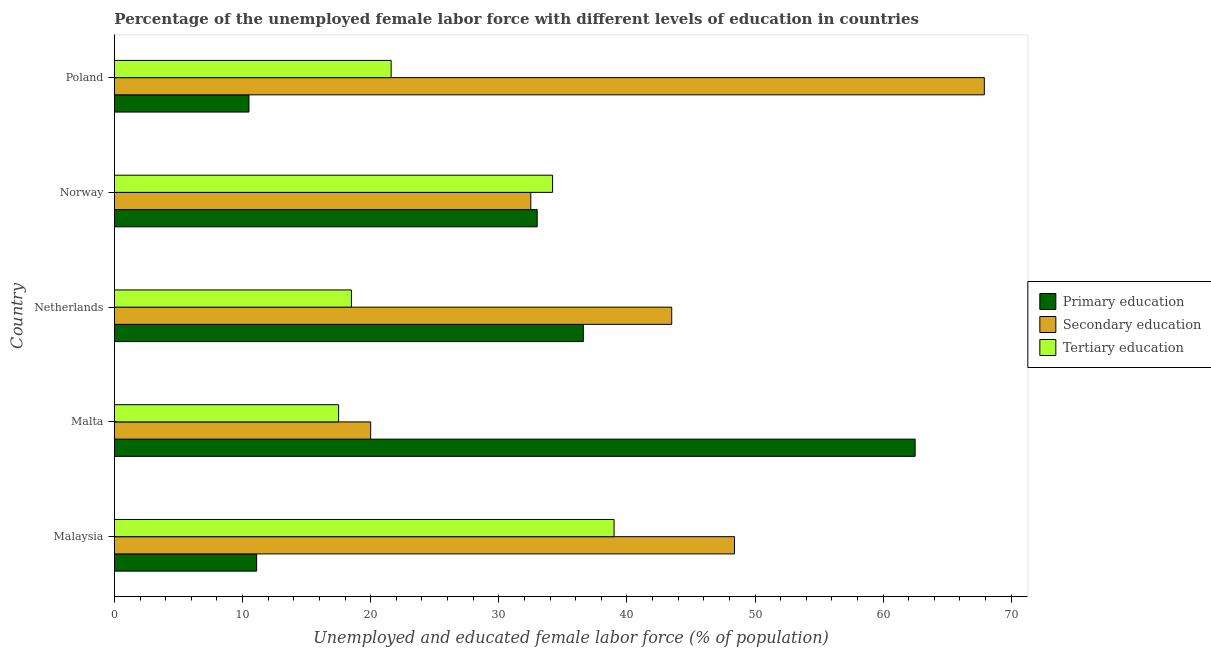How many groups of bars are there?
Offer a terse response. 5. Are the number of bars per tick equal to the number of legend labels?
Offer a very short reply. Yes. How many bars are there on the 5th tick from the bottom?
Provide a short and direct response. 3. In how many cases, is the number of bars for a given country not equal to the number of legend labels?
Keep it short and to the point. 0. Across all countries, what is the maximum percentage of female labor force who received primary education?
Provide a short and direct response. 62.5. Across all countries, what is the minimum percentage of female labor force who received secondary education?
Offer a very short reply. 20. In which country was the percentage of female labor force who received secondary education maximum?
Offer a very short reply. Poland. In which country was the percentage of female labor force who received secondary education minimum?
Provide a short and direct response. Malta. What is the total percentage of female labor force who received secondary education in the graph?
Provide a short and direct response. 212.3. What is the difference between the percentage of female labor force who received secondary education in Malaysia and the percentage of female labor force who received tertiary education in Netherlands?
Your answer should be very brief. 29.9. What is the average percentage of female labor force who received tertiary education per country?
Your answer should be very brief. 26.16. What is the difference between the percentage of female labor force who received tertiary education and percentage of female labor force who received secondary education in Poland?
Make the answer very short. -46.3. What is the ratio of the percentage of female labor force who received tertiary education in Netherlands to that in Poland?
Keep it short and to the point. 0.86. What is the difference between the highest and the second highest percentage of female labor force who received primary education?
Give a very brief answer. 25.9. What is the difference between the highest and the lowest percentage of female labor force who received secondary education?
Offer a terse response. 47.9. What does the 3rd bar from the top in Poland represents?
Give a very brief answer. Primary education. What does the 2nd bar from the bottom in Malaysia represents?
Your answer should be compact. Secondary education. Is it the case that in every country, the sum of the percentage of female labor force who received primary education and percentage of female labor force who received secondary education is greater than the percentage of female labor force who received tertiary education?
Offer a terse response. Yes. What is the difference between two consecutive major ticks on the X-axis?
Your answer should be very brief. 10. Does the graph contain any zero values?
Make the answer very short. No. Does the graph contain grids?
Keep it short and to the point. No. How many legend labels are there?
Provide a succinct answer. 3. What is the title of the graph?
Ensure brevity in your answer.  Percentage of the unemployed female labor force with different levels of education in countries. Does "Textiles and clothing" appear as one of the legend labels in the graph?
Give a very brief answer. No. What is the label or title of the X-axis?
Make the answer very short. Unemployed and educated female labor force (% of population). What is the Unemployed and educated female labor force (% of population) of Primary education in Malaysia?
Ensure brevity in your answer.  11.1. What is the Unemployed and educated female labor force (% of population) of Secondary education in Malaysia?
Keep it short and to the point. 48.4. What is the Unemployed and educated female labor force (% of population) in Tertiary education in Malaysia?
Ensure brevity in your answer.  39. What is the Unemployed and educated female labor force (% of population) of Primary education in Malta?
Your response must be concise. 62.5. What is the Unemployed and educated female labor force (% of population) in Secondary education in Malta?
Your response must be concise. 20. What is the Unemployed and educated female labor force (% of population) in Tertiary education in Malta?
Offer a terse response. 17.5. What is the Unemployed and educated female labor force (% of population) in Primary education in Netherlands?
Give a very brief answer. 36.6. What is the Unemployed and educated female labor force (% of population) in Secondary education in Netherlands?
Offer a very short reply. 43.5. What is the Unemployed and educated female labor force (% of population) of Secondary education in Norway?
Offer a terse response. 32.5. What is the Unemployed and educated female labor force (% of population) of Tertiary education in Norway?
Offer a terse response. 34.2. What is the Unemployed and educated female labor force (% of population) in Secondary education in Poland?
Offer a very short reply. 67.9. What is the Unemployed and educated female labor force (% of population) in Tertiary education in Poland?
Your response must be concise. 21.6. Across all countries, what is the maximum Unemployed and educated female labor force (% of population) in Primary education?
Ensure brevity in your answer.  62.5. Across all countries, what is the maximum Unemployed and educated female labor force (% of population) of Secondary education?
Ensure brevity in your answer.  67.9. Across all countries, what is the maximum Unemployed and educated female labor force (% of population) in Tertiary education?
Keep it short and to the point. 39. Across all countries, what is the minimum Unemployed and educated female labor force (% of population) in Secondary education?
Provide a short and direct response. 20. What is the total Unemployed and educated female labor force (% of population) of Primary education in the graph?
Your answer should be very brief. 153.7. What is the total Unemployed and educated female labor force (% of population) in Secondary education in the graph?
Your answer should be compact. 212.3. What is the total Unemployed and educated female labor force (% of population) of Tertiary education in the graph?
Offer a terse response. 130.8. What is the difference between the Unemployed and educated female labor force (% of population) in Primary education in Malaysia and that in Malta?
Provide a short and direct response. -51.4. What is the difference between the Unemployed and educated female labor force (% of population) in Secondary education in Malaysia and that in Malta?
Give a very brief answer. 28.4. What is the difference between the Unemployed and educated female labor force (% of population) in Tertiary education in Malaysia and that in Malta?
Offer a very short reply. 21.5. What is the difference between the Unemployed and educated female labor force (% of population) of Primary education in Malaysia and that in Netherlands?
Ensure brevity in your answer.  -25.5. What is the difference between the Unemployed and educated female labor force (% of population) of Secondary education in Malaysia and that in Netherlands?
Keep it short and to the point. 4.9. What is the difference between the Unemployed and educated female labor force (% of population) in Primary education in Malaysia and that in Norway?
Offer a very short reply. -21.9. What is the difference between the Unemployed and educated female labor force (% of population) in Tertiary education in Malaysia and that in Norway?
Keep it short and to the point. 4.8. What is the difference between the Unemployed and educated female labor force (% of population) in Secondary education in Malaysia and that in Poland?
Offer a very short reply. -19.5. What is the difference between the Unemployed and educated female labor force (% of population) in Primary education in Malta and that in Netherlands?
Keep it short and to the point. 25.9. What is the difference between the Unemployed and educated female labor force (% of population) of Secondary education in Malta and that in Netherlands?
Give a very brief answer. -23.5. What is the difference between the Unemployed and educated female labor force (% of population) in Primary education in Malta and that in Norway?
Your answer should be very brief. 29.5. What is the difference between the Unemployed and educated female labor force (% of population) of Tertiary education in Malta and that in Norway?
Offer a terse response. -16.7. What is the difference between the Unemployed and educated female labor force (% of population) in Secondary education in Malta and that in Poland?
Provide a short and direct response. -47.9. What is the difference between the Unemployed and educated female labor force (% of population) of Secondary education in Netherlands and that in Norway?
Make the answer very short. 11. What is the difference between the Unemployed and educated female labor force (% of population) of Tertiary education in Netherlands and that in Norway?
Keep it short and to the point. -15.7. What is the difference between the Unemployed and educated female labor force (% of population) in Primary education in Netherlands and that in Poland?
Provide a succinct answer. 26.1. What is the difference between the Unemployed and educated female labor force (% of population) in Secondary education in Netherlands and that in Poland?
Offer a very short reply. -24.4. What is the difference between the Unemployed and educated female labor force (% of population) of Secondary education in Norway and that in Poland?
Offer a terse response. -35.4. What is the difference between the Unemployed and educated female labor force (% of population) of Tertiary education in Norway and that in Poland?
Ensure brevity in your answer.  12.6. What is the difference between the Unemployed and educated female labor force (% of population) in Primary education in Malaysia and the Unemployed and educated female labor force (% of population) in Tertiary education in Malta?
Make the answer very short. -6.4. What is the difference between the Unemployed and educated female labor force (% of population) of Secondary education in Malaysia and the Unemployed and educated female labor force (% of population) of Tertiary education in Malta?
Your answer should be very brief. 30.9. What is the difference between the Unemployed and educated female labor force (% of population) in Primary education in Malaysia and the Unemployed and educated female labor force (% of population) in Secondary education in Netherlands?
Ensure brevity in your answer.  -32.4. What is the difference between the Unemployed and educated female labor force (% of population) of Primary education in Malaysia and the Unemployed and educated female labor force (% of population) of Tertiary education in Netherlands?
Your answer should be compact. -7.4. What is the difference between the Unemployed and educated female labor force (% of population) in Secondary education in Malaysia and the Unemployed and educated female labor force (% of population) in Tertiary education in Netherlands?
Offer a terse response. 29.9. What is the difference between the Unemployed and educated female labor force (% of population) in Primary education in Malaysia and the Unemployed and educated female labor force (% of population) in Secondary education in Norway?
Ensure brevity in your answer.  -21.4. What is the difference between the Unemployed and educated female labor force (% of population) in Primary education in Malaysia and the Unemployed and educated female labor force (% of population) in Tertiary education in Norway?
Keep it short and to the point. -23.1. What is the difference between the Unemployed and educated female labor force (% of population) in Primary education in Malaysia and the Unemployed and educated female labor force (% of population) in Secondary education in Poland?
Your response must be concise. -56.8. What is the difference between the Unemployed and educated female labor force (% of population) of Primary education in Malaysia and the Unemployed and educated female labor force (% of population) of Tertiary education in Poland?
Your response must be concise. -10.5. What is the difference between the Unemployed and educated female labor force (% of population) in Secondary education in Malaysia and the Unemployed and educated female labor force (% of population) in Tertiary education in Poland?
Provide a succinct answer. 26.8. What is the difference between the Unemployed and educated female labor force (% of population) of Primary education in Malta and the Unemployed and educated female labor force (% of population) of Secondary education in Netherlands?
Your answer should be very brief. 19. What is the difference between the Unemployed and educated female labor force (% of population) in Primary education in Malta and the Unemployed and educated female labor force (% of population) in Secondary education in Norway?
Keep it short and to the point. 30. What is the difference between the Unemployed and educated female labor force (% of population) of Primary education in Malta and the Unemployed and educated female labor force (% of population) of Tertiary education in Norway?
Make the answer very short. 28.3. What is the difference between the Unemployed and educated female labor force (% of population) in Primary education in Malta and the Unemployed and educated female labor force (% of population) in Secondary education in Poland?
Make the answer very short. -5.4. What is the difference between the Unemployed and educated female labor force (% of population) in Primary education in Malta and the Unemployed and educated female labor force (% of population) in Tertiary education in Poland?
Offer a terse response. 40.9. What is the difference between the Unemployed and educated female labor force (% of population) in Primary education in Netherlands and the Unemployed and educated female labor force (% of population) in Tertiary education in Norway?
Provide a succinct answer. 2.4. What is the difference between the Unemployed and educated female labor force (% of population) of Primary education in Netherlands and the Unemployed and educated female labor force (% of population) of Secondary education in Poland?
Your answer should be very brief. -31.3. What is the difference between the Unemployed and educated female labor force (% of population) of Primary education in Netherlands and the Unemployed and educated female labor force (% of population) of Tertiary education in Poland?
Provide a short and direct response. 15. What is the difference between the Unemployed and educated female labor force (% of population) in Secondary education in Netherlands and the Unemployed and educated female labor force (% of population) in Tertiary education in Poland?
Ensure brevity in your answer.  21.9. What is the difference between the Unemployed and educated female labor force (% of population) of Primary education in Norway and the Unemployed and educated female labor force (% of population) of Secondary education in Poland?
Provide a short and direct response. -34.9. What is the average Unemployed and educated female labor force (% of population) in Primary education per country?
Keep it short and to the point. 30.74. What is the average Unemployed and educated female labor force (% of population) of Secondary education per country?
Your response must be concise. 42.46. What is the average Unemployed and educated female labor force (% of population) of Tertiary education per country?
Offer a terse response. 26.16. What is the difference between the Unemployed and educated female labor force (% of population) in Primary education and Unemployed and educated female labor force (% of population) in Secondary education in Malaysia?
Provide a short and direct response. -37.3. What is the difference between the Unemployed and educated female labor force (% of population) in Primary education and Unemployed and educated female labor force (% of population) in Tertiary education in Malaysia?
Ensure brevity in your answer.  -27.9. What is the difference between the Unemployed and educated female labor force (% of population) of Secondary education and Unemployed and educated female labor force (% of population) of Tertiary education in Malaysia?
Provide a short and direct response. 9.4. What is the difference between the Unemployed and educated female labor force (% of population) in Primary education and Unemployed and educated female labor force (% of population) in Secondary education in Malta?
Ensure brevity in your answer.  42.5. What is the difference between the Unemployed and educated female labor force (% of population) in Secondary education and Unemployed and educated female labor force (% of population) in Tertiary education in Malta?
Your answer should be compact. 2.5. What is the difference between the Unemployed and educated female labor force (% of population) of Primary education and Unemployed and educated female labor force (% of population) of Secondary education in Netherlands?
Your answer should be very brief. -6.9. What is the difference between the Unemployed and educated female labor force (% of population) in Primary education and Unemployed and educated female labor force (% of population) in Tertiary education in Netherlands?
Your answer should be compact. 18.1. What is the difference between the Unemployed and educated female labor force (% of population) in Primary education and Unemployed and educated female labor force (% of population) in Tertiary education in Norway?
Offer a very short reply. -1.2. What is the difference between the Unemployed and educated female labor force (% of population) of Secondary education and Unemployed and educated female labor force (% of population) of Tertiary education in Norway?
Provide a succinct answer. -1.7. What is the difference between the Unemployed and educated female labor force (% of population) of Primary education and Unemployed and educated female labor force (% of population) of Secondary education in Poland?
Provide a short and direct response. -57.4. What is the difference between the Unemployed and educated female labor force (% of population) of Primary education and Unemployed and educated female labor force (% of population) of Tertiary education in Poland?
Your answer should be very brief. -11.1. What is the difference between the Unemployed and educated female labor force (% of population) of Secondary education and Unemployed and educated female labor force (% of population) of Tertiary education in Poland?
Offer a very short reply. 46.3. What is the ratio of the Unemployed and educated female labor force (% of population) of Primary education in Malaysia to that in Malta?
Keep it short and to the point. 0.18. What is the ratio of the Unemployed and educated female labor force (% of population) in Secondary education in Malaysia to that in Malta?
Your answer should be very brief. 2.42. What is the ratio of the Unemployed and educated female labor force (% of population) in Tertiary education in Malaysia to that in Malta?
Provide a succinct answer. 2.23. What is the ratio of the Unemployed and educated female labor force (% of population) in Primary education in Malaysia to that in Netherlands?
Keep it short and to the point. 0.3. What is the ratio of the Unemployed and educated female labor force (% of population) in Secondary education in Malaysia to that in Netherlands?
Offer a terse response. 1.11. What is the ratio of the Unemployed and educated female labor force (% of population) in Tertiary education in Malaysia to that in Netherlands?
Your response must be concise. 2.11. What is the ratio of the Unemployed and educated female labor force (% of population) in Primary education in Malaysia to that in Norway?
Make the answer very short. 0.34. What is the ratio of the Unemployed and educated female labor force (% of population) of Secondary education in Malaysia to that in Norway?
Provide a short and direct response. 1.49. What is the ratio of the Unemployed and educated female labor force (% of population) in Tertiary education in Malaysia to that in Norway?
Make the answer very short. 1.14. What is the ratio of the Unemployed and educated female labor force (% of population) of Primary education in Malaysia to that in Poland?
Give a very brief answer. 1.06. What is the ratio of the Unemployed and educated female labor force (% of population) in Secondary education in Malaysia to that in Poland?
Provide a succinct answer. 0.71. What is the ratio of the Unemployed and educated female labor force (% of population) in Tertiary education in Malaysia to that in Poland?
Your answer should be very brief. 1.81. What is the ratio of the Unemployed and educated female labor force (% of population) of Primary education in Malta to that in Netherlands?
Your answer should be compact. 1.71. What is the ratio of the Unemployed and educated female labor force (% of population) in Secondary education in Malta to that in Netherlands?
Your answer should be very brief. 0.46. What is the ratio of the Unemployed and educated female labor force (% of population) in Tertiary education in Malta to that in Netherlands?
Your answer should be very brief. 0.95. What is the ratio of the Unemployed and educated female labor force (% of population) in Primary education in Malta to that in Norway?
Give a very brief answer. 1.89. What is the ratio of the Unemployed and educated female labor force (% of population) of Secondary education in Malta to that in Norway?
Your answer should be very brief. 0.62. What is the ratio of the Unemployed and educated female labor force (% of population) in Tertiary education in Malta to that in Norway?
Your response must be concise. 0.51. What is the ratio of the Unemployed and educated female labor force (% of population) of Primary education in Malta to that in Poland?
Keep it short and to the point. 5.95. What is the ratio of the Unemployed and educated female labor force (% of population) in Secondary education in Malta to that in Poland?
Provide a succinct answer. 0.29. What is the ratio of the Unemployed and educated female labor force (% of population) of Tertiary education in Malta to that in Poland?
Give a very brief answer. 0.81. What is the ratio of the Unemployed and educated female labor force (% of population) in Primary education in Netherlands to that in Norway?
Your answer should be very brief. 1.11. What is the ratio of the Unemployed and educated female labor force (% of population) of Secondary education in Netherlands to that in Norway?
Give a very brief answer. 1.34. What is the ratio of the Unemployed and educated female labor force (% of population) of Tertiary education in Netherlands to that in Norway?
Give a very brief answer. 0.54. What is the ratio of the Unemployed and educated female labor force (% of population) in Primary education in Netherlands to that in Poland?
Provide a short and direct response. 3.49. What is the ratio of the Unemployed and educated female labor force (% of population) of Secondary education in Netherlands to that in Poland?
Make the answer very short. 0.64. What is the ratio of the Unemployed and educated female labor force (% of population) in Tertiary education in Netherlands to that in Poland?
Make the answer very short. 0.86. What is the ratio of the Unemployed and educated female labor force (% of population) in Primary education in Norway to that in Poland?
Keep it short and to the point. 3.14. What is the ratio of the Unemployed and educated female labor force (% of population) of Secondary education in Norway to that in Poland?
Offer a terse response. 0.48. What is the ratio of the Unemployed and educated female labor force (% of population) of Tertiary education in Norway to that in Poland?
Offer a very short reply. 1.58. What is the difference between the highest and the second highest Unemployed and educated female labor force (% of population) of Primary education?
Ensure brevity in your answer.  25.9. What is the difference between the highest and the lowest Unemployed and educated female labor force (% of population) of Secondary education?
Your answer should be compact. 47.9. What is the difference between the highest and the lowest Unemployed and educated female labor force (% of population) of Tertiary education?
Offer a very short reply. 21.5. 